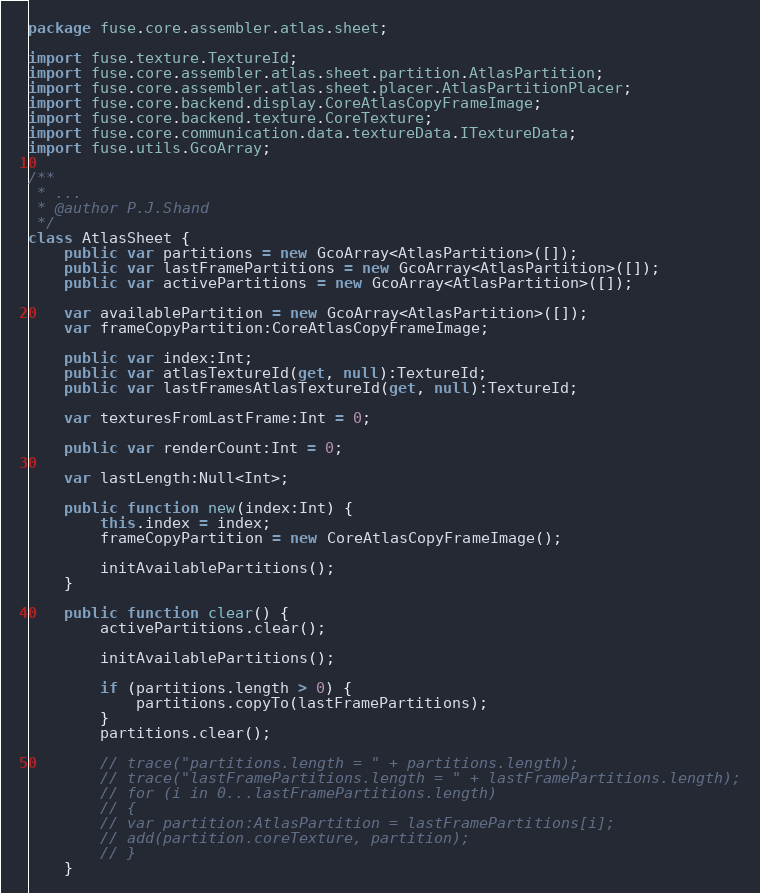<code> <loc_0><loc_0><loc_500><loc_500><_Haxe_>package fuse.core.assembler.atlas.sheet;

import fuse.texture.TextureId;
import fuse.core.assembler.atlas.sheet.partition.AtlasPartition;
import fuse.core.assembler.atlas.sheet.placer.AtlasPartitionPlacer;
import fuse.core.backend.display.CoreAtlasCopyFrameImage;
import fuse.core.backend.texture.CoreTexture;
import fuse.core.communication.data.textureData.ITextureData;
import fuse.utils.GcoArray;

/**
 * ...
 * @author P.J.Shand
 */
class AtlasSheet {
	public var partitions = new GcoArray<AtlasPartition>([]);
	public var lastFramePartitions = new GcoArray<AtlasPartition>([]);
	public var activePartitions = new GcoArray<AtlasPartition>([]);

	var availablePartition = new GcoArray<AtlasPartition>([]);
	var frameCopyPartition:CoreAtlasCopyFrameImage;

	public var index:Int;
	public var atlasTextureId(get, null):TextureId;
	public var lastFramesAtlasTextureId(get, null):TextureId;

	var texturesFromLastFrame:Int = 0;

	public var renderCount:Int = 0;

	var lastLength:Null<Int>;

	public function new(index:Int) {
		this.index = index;
		frameCopyPartition = new CoreAtlasCopyFrameImage();

		initAvailablePartitions();
	}

	public function clear() {
		activePartitions.clear();

		initAvailablePartitions();

		if (partitions.length > 0) {
			partitions.copyTo(lastFramePartitions);
		}
		partitions.clear();

		// trace("partitions.length = " + partitions.length);
		// trace("lastFramePartitions.length = " + lastFramePartitions.length);
		// for (i in 0...lastFramePartitions.length)
		// {
		// var partition:AtlasPartition = lastFramePartitions[i];
		// add(partition.coreTexture, partition);
		// }
	}
</code> 